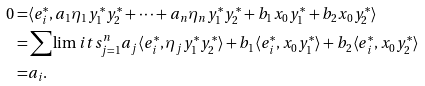<formula> <loc_0><loc_0><loc_500><loc_500>0 = & \langle e _ { i } ^ { * } , a _ { 1 } \eta _ { 1 } y _ { 1 } ^ { * } y _ { 2 } ^ { * } + \cdots + a _ { n } \eta _ { n } y _ { 1 } ^ { * } y _ { 2 } ^ { * } + b _ { 1 } x _ { 0 } y _ { 1 } ^ { * } + b _ { 2 } x _ { 0 } y _ { 2 } ^ { * } \rangle \\ = & \sum \lim i t s _ { j = 1 } ^ { n } a _ { j } \langle e _ { i } ^ { * } , \eta _ { j } y _ { 1 } ^ { * } y _ { 2 } ^ { * } \rangle + b _ { 1 } \langle e _ { i } ^ { * } , x _ { 0 } y _ { 1 } ^ { * } \rangle + b _ { 2 } \langle e _ { i } ^ { * } , x _ { 0 } y _ { 2 } ^ { * } \rangle \\ = & a _ { i } . \quad \, \quad</formula> 